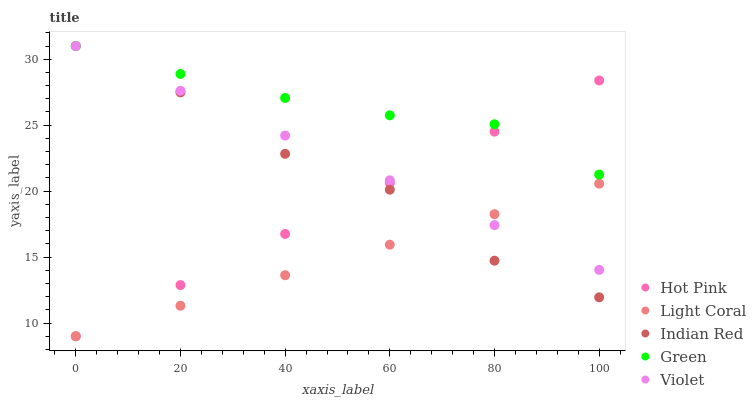Does Light Coral have the minimum area under the curve?
Answer yes or no. Yes. Does Green have the maximum area under the curve?
Answer yes or no. Yes. Does Hot Pink have the minimum area under the curve?
Answer yes or no. No. Does Hot Pink have the maximum area under the curve?
Answer yes or no. No. Is Hot Pink the smoothest?
Answer yes or no. Yes. Is Indian Red the roughest?
Answer yes or no. Yes. Is Green the smoothest?
Answer yes or no. No. Is Green the roughest?
Answer yes or no. No. Does Light Coral have the lowest value?
Answer yes or no. Yes. Does Green have the lowest value?
Answer yes or no. No. Does Violet have the highest value?
Answer yes or no. Yes. Does Hot Pink have the highest value?
Answer yes or no. No. Is Light Coral less than Green?
Answer yes or no. Yes. Is Green greater than Light Coral?
Answer yes or no. Yes. Does Light Coral intersect Indian Red?
Answer yes or no. Yes. Is Light Coral less than Indian Red?
Answer yes or no. No. Is Light Coral greater than Indian Red?
Answer yes or no. No. Does Light Coral intersect Green?
Answer yes or no. No. 